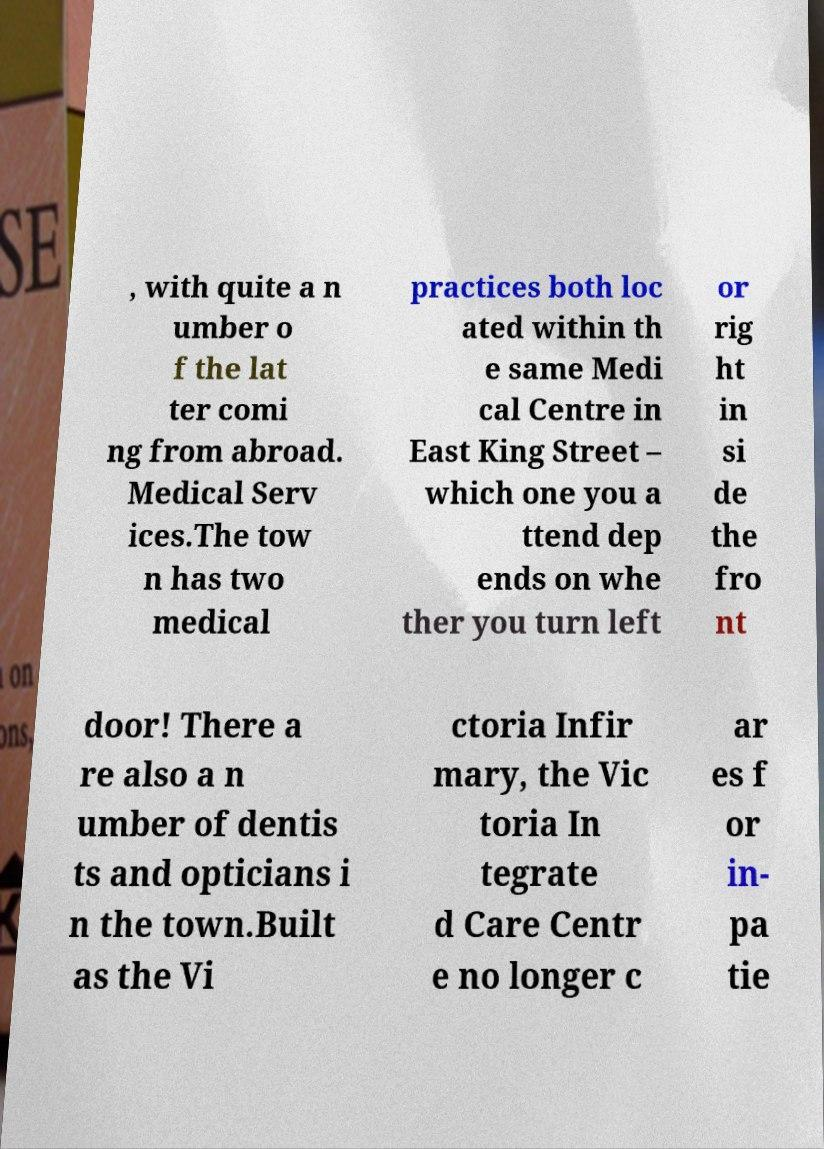I need the written content from this picture converted into text. Can you do that? , with quite a n umber o f the lat ter comi ng from abroad. Medical Serv ices.The tow n has two medical practices both loc ated within th e same Medi cal Centre in East King Street – which one you a ttend dep ends on whe ther you turn left or rig ht in si de the fro nt door! There a re also a n umber of dentis ts and opticians i n the town.Built as the Vi ctoria Infir mary, the Vic toria In tegrate d Care Centr e no longer c ar es f or in- pa tie 